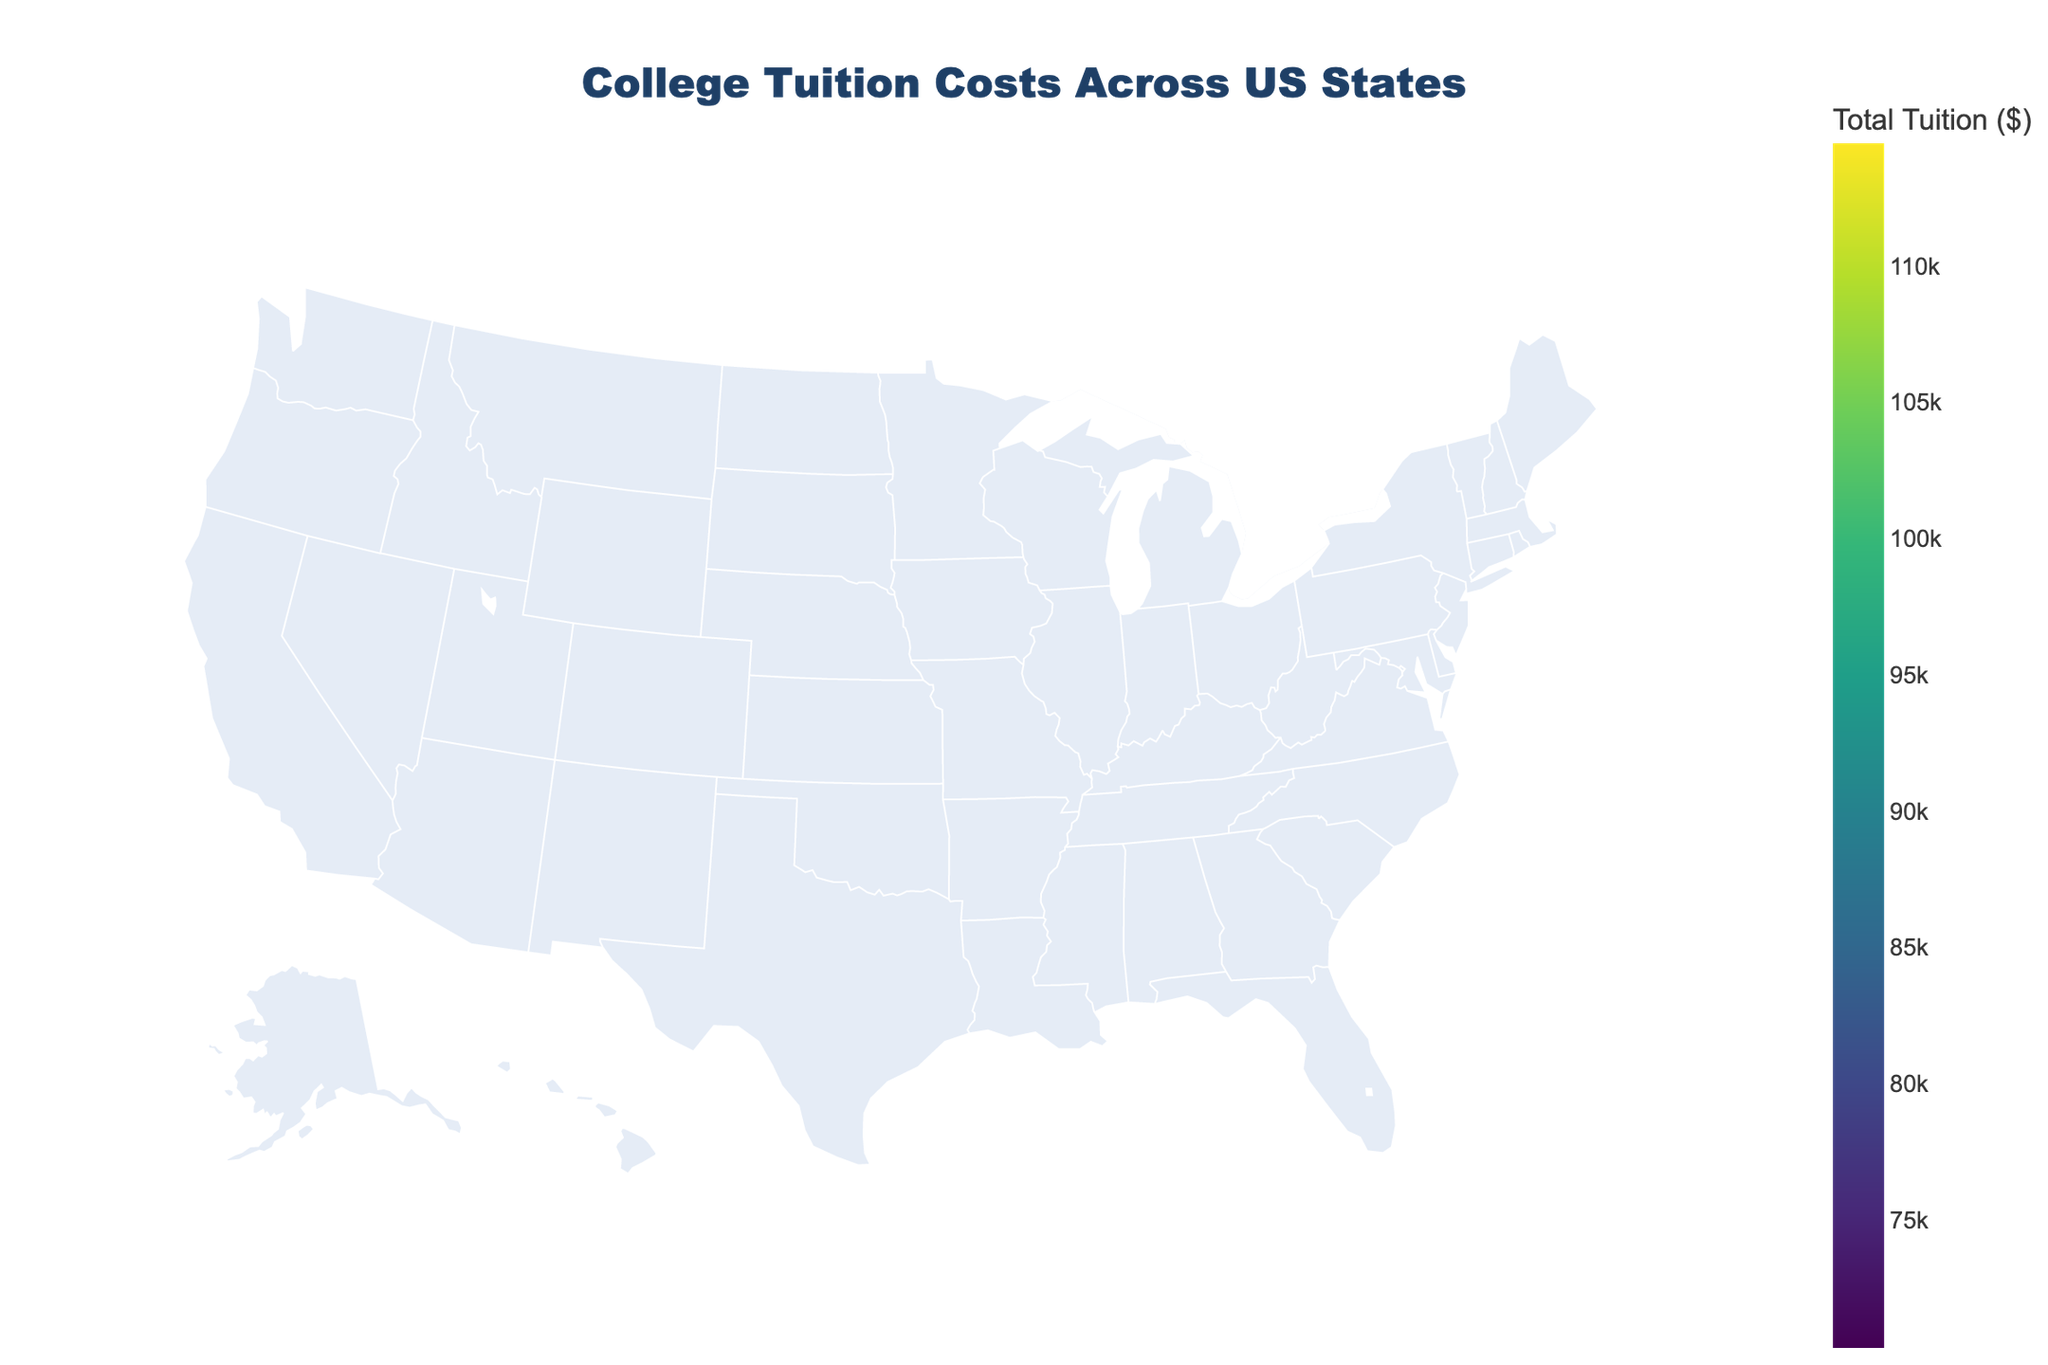What's the title of the figure? The title of the figure is prominently displayed at the top.
Answer: College Tuition Costs Across US States Which state has the highest private tuition cost according to the figure? To find this, look at the hover information for each state and compare the private tuition costs. Massachusetts has the highest private tuition cost.
Answer: Massachusetts Which state has the lowest public in-state tuition cost? Hover over each state to compare the public in-state tuition costs. Florida has the lowest public in-state tuition cost.
Answer: Florida What is the total tuition cost for California? Hover over California to see the breakdown. Sum the public in-state ($14,100), public out-of-state ($43,900), and private tuition ($54,800) costs. $14100 + $43900 + $54800 = $112800.
Answer: $112800 How does the public out-of-state tuition in Texas compare to that in Florida? Compare the numerical values for public out-of-state tuition for both states via the hover text. Texas has a public out-of-state tuition of $28,700, while Florida's is $21,800. Texas is higher.
Answer: Texas is higher If you need to move to another state for lower total tuition costs for your child, which state has a lower total tuition cost than Pennsylvania? Check and compare the total tuition displayed on hover for different states. Pennsylvania's total is $104500. States with lower total tuition include: Florida, Texas, Ohio, Georgia, North Carolina, Washington, Colorado, Arizona, and Virginia.
Answer: Multiple states (listed in explanation) Which state has the biggest difference between public in-state and out-of-state tuition? Look for the largest disparity between these two tuition costs for each state in the hover text. Michigan shows the largest difference, $51,200 - $15,900 = $35,300.
Answer: Michigan Is the average private tuition in the figure higher or lower than $50,000? Calculate the average for private tuitions: (54800 + 58700 + 49200 + 42100 + 61500 + 52400 + 55900 + 47200 + 44100 + 50200 + 44000 + 47200 + 50900 + 51900 + 40600) / 15 = 52140. The average is higher.
Answer: Higher Which state has the highest total tuition? Compare the 'Total Tuition' values calculated for each state. Massachusetts has the highest total tuition.
Answer: Massachusetts 